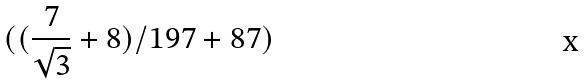<formula> <loc_0><loc_0><loc_500><loc_500>( ( \frac { 7 } { \sqrt { 3 } } + 8 ) / 1 9 7 + 8 7 )</formula> 